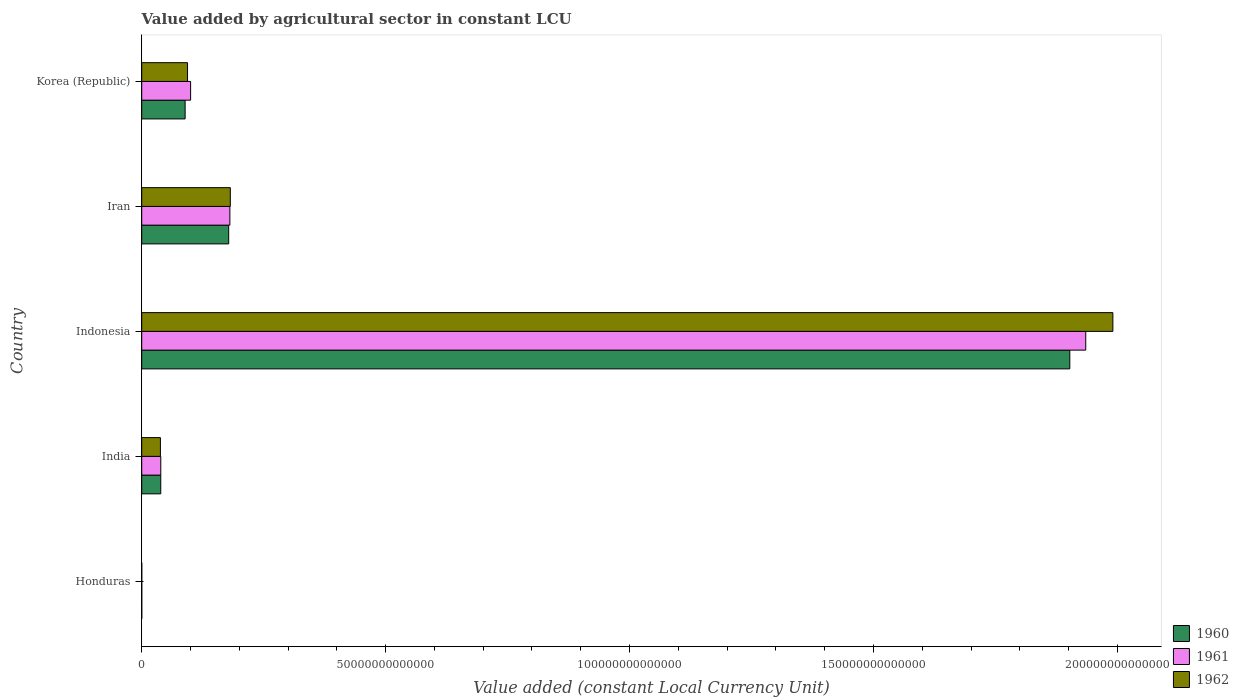Are the number of bars per tick equal to the number of legend labels?
Provide a succinct answer. Yes. Are the number of bars on each tick of the Y-axis equal?
Keep it short and to the point. Yes. How many bars are there on the 4th tick from the top?
Provide a short and direct response. 3. In how many cases, is the number of bars for a given country not equal to the number of legend labels?
Offer a very short reply. 0. What is the value added by agricultural sector in 1962 in Korea (Republic)?
Your response must be concise. 9.39e+12. Across all countries, what is the maximum value added by agricultural sector in 1962?
Ensure brevity in your answer.  1.99e+14. Across all countries, what is the minimum value added by agricultural sector in 1962?
Your response must be concise. 4.96e+09. In which country was the value added by agricultural sector in 1960 maximum?
Provide a succinct answer. Indonesia. In which country was the value added by agricultural sector in 1960 minimum?
Provide a short and direct response. Honduras. What is the total value added by agricultural sector in 1960 in the graph?
Provide a short and direct response. 2.21e+14. What is the difference between the value added by agricultural sector in 1962 in Honduras and that in Indonesia?
Your response must be concise. -1.99e+14. What is the difference between the value added by agricultural sector in 1961 in India and the value added by agricultural sector in 1960 in Korea (Republic)?
Give a very brief answer. -4.99e+12. What is the average value added by agricultural sector in 1962 per country?
Give a very brief answer. 4.61e+13. What is the difference between the value added by agricultural sector in 1962 and value added by agricultural sector in 1961 in Indonesia?
Provide a succinct answer. 5.56e+12. What is the ratio of the value added by agricultural sector in 1962 in Honduras to that in Korea (Republic)?
Your answer should be very brief. 0. Is the value added by agricultural sector in 1960 in Honduras less than that in Korea (Republic)?
Your response must be concise. Yes. What is the difference between the highest and the second highest value added by agricultural sector in 1962?
Your answer should be compact. 1.81e+14. What is the difference between the highest and the lowest value added by agricultural sector in 1960?
Your answer should be very brief. 1.90e+14. In how many countries, is the value added by agricultural sector in 1961 greater than the average value added by agricultural sector in 1961 taken over all countries?
Make the answer very short. 1. Is the sum of the value added by agricultural sector in 1962 in Indonesia and Iran greater than the maximum value added by agricultural sector in 1961 across all countries?
Provide a succinct answer. Yes. What does the 1st bar from the bottom in Korea (Republic) represents?
Make the answer very short. 1960. How many bars are there?
Provide a short and direct response. 15. Are all the bars in the graph horizontal?
Keep it short and to the point. Yes. How many countries are there in the graph?
Your answer should be compact. 5. What is the difference between two consecutive major ticks on the X-axis?
Your response must be concise. 5.00e+13. Are the values on the major ticks of X-axis written in scientific E-notation?
Your answer should be compact. No. Does the graph contain grids?
Your answer should be compact. No. How are the legend labels stacked?
Your response must be concise. Vertical. What is the title of the graph?
Ensure brevity in your answer.  Value added by agricultural sector in constant LCU. What is the label or title of the X-axis?
Your answer should be very brief. Value added (constant Local Currency Unit). What is the label or title of the Y-axis?
Give a very brief answer. Country. What is the Value added (constant Local Currency Unit) of 1960 in Honduras?
Offer a terse response. 4.44e+09. What is the Value added (constant Local Currency Unit) of 1961 in Honduras?
Provide a short and direct response. 4.73e+09. What is the Value added (constant Local Currency Unit) in 1962 in Honduras?
Ensure brevity in your answer.  4.96e+09. What is the Value added (constant Local Currency Unit) of 1960 in India?
Offer a terse response. 3.90e+12. What is the Value added (constant Local Currency Unit) in 1961 in India?
Offer a very short reply. 3.91e+12. What is the Value added (constant Local Currency Unit) of 1962 in India?
Offer a terse response. 3.83e+12. What is the Value added (constant Local Currency Unit) in 1960 in Indonesia?
Keep it short and to the point. 1.90e+14. What is the Value added (constant Local Currency Unit) in 1961 in Indonesia?
Ensure brevity in your answer.  1.94e+14. What is the Value added (constant Local Currency Unit) in 1962 in Indonesia?
Provide a succinct answer. 1.99e+14. What is the Value added (constant Local Currency Unit) in 1960 in Iran?
Give a very brief answer. 1.78e+13. What is the Value added (constant Local Currency Unit) of 1961 in Iran?
Offer a terse response. 1.81e+13. What is the Value added (constant Local Currency Unit) in 1962 in Iran?
Provide a succinct answer. 1.82e+13. What is the Value added (constant Local Currency Unit) in 1960 in Korea (Republic)?
Provide a succinct answer. 8.90e+12. What is the Value added (constant Local Currency Unit) in 1961 in Korea (Republic)?
Provide a succinct answer. 1.00e+13. What is the Value added (constant Local Currency Unit) of 1962 in Korea (Republic)?
Make the answer very short. 9.39e+12. Across all countries, what is the maximum Value added (constant Local Currency Unit) in 1960?
Keep it short and to the point. 1.90e+14. Across all countries, what is the maximum Value added (constant Local Currency Unit) in 1961?
Ensure brevity in your answer.  1.94e+14. Across all countries, what is the maximum Value added (constant Local Currency Unit) in 1962?
Your response must be concise. 1.99e+14. Across all countries, what is the minimum Value added (constant Local Currency Unit) in 1960?
Your answer should be very brief. 4.44e+09. Across all countries, what is the minimum Value added (constant Local Currency Unit) of 1961?
Ensure brevity in your answer.  4.73e+09. Across all countries, what is the minimum Value added (constant Local Currency Unit) in 1962?
Your answer should be compact. 4.96e+09. What is the total Value added (constant Local Currency Unit) of 1960 in the graph?
Your answer should be compact. 2.21e+14. What is the total Value added (constant Local Currency Unit) of 1961 in the graph?
Provide a short and direct response. 2.26e+14. What is the total Value added (constant Local Currency Unit) of 1962 in the graph?
Make the answer very short. 2.30e+14. What is the difference between the Value added (constant Local Currency Unit) in 1960 in Honduras and that in India?
Make the answer very short. -3.90e+12. What is the difference between the Value added (constant Local Currency Unit) of 1961 in Honduras and that in India?
Give a very brief answer. -3.90e+12. What is the difference between the Value added (constant Local Currency Unit) of 1962 in Honduras and that in India?
Your answer should be compact. -3.82e+12. What is the difference between the Value added (constant Local Currency Unit) in 1960 in Honduras and that in Indonesia?
Offer a very short reply. -1.90e+14. What is the difference between the Value added (constant Local Currency Unit) in 1961 in Honduras and that in Indonesia?
Your answer should be compact. -1.94e+14. What is the difference between the Value added (constant Local Currency Unit) in 1962 in Honduras and that in Indonesia?
Offer a terse response. -1.99e+14. What is the difference between the Value added (constant Local Currency Unit) of 1960 in Honduras and that in Iran?
Ensure brevity in your answer.  -1.78e+13. What is the difference between the Value added (constant Local Currency Unit) of 1961 in Honduras and that in Iran?
Offer a very short reply. -1.81e+13. What is the difference between the Value added (constant Local Currency Unit) of 1962 in Honduras and that in Iran?
Offer a very short reply. -1.82e+13. What is the difference between the Value added (constant Local Currency Unit) of 1960 in Honduras and that in Korea (Republic)?
Offer a very short reply. -8.89e+12. What is the difference between the Value added (constant Local Currency Unit) of 1961 in Honduras and that in Korea (Republic)?
Your answer should be compact. -1.00e+13. What is the difference between the Value added (constant Local Currency Unit) in 1962 in Honduras and that in Korea (Republic)?
Keep it short and to the point. -9.39e+12. What is the difference between the Value added (constant Local Currency Unit) in 1960 in India and that in Indonesia?
Keep it short and to the point. -1.86e+14. What is the difference between the Value added (constant Local Currency Unit) in 1961 in India and that in Indonesia?
Offer a very short reply. -1.90e+14. What is the difference between the Value added (constant Local Currency Unit) in 1962 in India and that in Indonesia?
Offer a very short reply. -1.95e+14. What is the difference between the Value added (constant Local Currency Unit) in 1960 in India and that in Iran?
Your response must be concise. -1.39e+13. What is the difference between the Value added (constant Local Currency Unit) in 1961 in India and that in Iran?
Your response must be concise. -1.42e+13. What is the difference between the Value added (constant Local Currency Unit) of 1962 in India and that in Iran?
Offer a terse response. -1.43e+13. What is the difference between the Value added (constant Local Currency Unit) of 1960 in India and that in Korea (Republic)?
Make the answer very short. -4.99e+12. What is the difference between the Value added (constant Local Currency Unit) in 1961 in India and that in Korea (Republic)?
Keep it short and to the point. -6.11e+12. What is the difference between the Value added (constant Local Currency Unit) in 1962 in India and that in Korea (Republic)?
Your response must be concise. -5.56e+12. What is the difference between the Value added (constant Local Currency Unit) in 1960 in Indonesia and that in Iran?
Keep it short and to the point. 1.72e+14. What is the difference between the Value added (constant Local Currency Unit) in 1961 in Indonesia and that in Iran?
Your answer should be compact. 1.75e+14. What is the difference between the Value added (constant Local Currency Unit) of 1962 in Indonesia and that in Iran?
Provide a succinct answer. 1.81e+14. What is the difference between the Value added (constant Local Currency Unit) of 1960 in Indonesia and that in Korea (Republic)?
Provide a short and direct response. 1.81e+14. What is the difference between the Value added (constant Local Currency Unit) of 1961 in Indonesia and that in Korea (Republic)?
Provide a succinct answer. 1.83e+14. What is the difference between the Value added (constant Local Currency Unit) of 1962 in Indonesia and that in Korea (Republic)?
Give a very brief answer. 1.90e+14. What is the difference between the Value added (constant Local Currency Unit) in 1960 in Iran and that in Korea (Republic)?
Ensure brevity in your answer.  8.93e+12. What is the difference between the Value added (constant Local Currency Unit) of 1961 in Iran and that in Korea (Republic)?
Ensure brevity in your answer.  8.05e+12. What is the difference between the Value added (constant Local Currency Unit) of 1962 in Iran and that in Korea (Republic)?
Provide a short and direct response. 8.77e+12. What is the difference between the Value added (constant Local Currency Unit) in 1960 in Honduras and the Value added (constant Local Currency Unit) in 1961 in India?
Your response must be concise. -3.90e+12. What is the difference between the Value added (constant Local Currency Unit) of 1960 in Honduras and the Value added (constant Local Currency Unit) of 1962 in India?
Provide a succinct answer. -3.83e+12. What is the difference between the Value added (constant Local Currency Unit) in 1961 in Honduras and the Value added (constant Local Currency Unit) in 1962 in India?
Offer a very short reply. -3.83e+12. What is the difference between the Value added (constant Local Currency Unit) in 1960 in Honduras and the Value added (constant Local Currency Unit) in 1961 in Indonesia?
Your answer should be compact. -1.94e+14. What is the difference between the Value added (constant Local Currency Unit) in 1960 in Honduras and the Value added (constant Local Currency Unit) in 1962 in Indonesia?
Your answer should be compact. -1.99e+14. What is the difference between the Value added (constant Local Currency Unit) of 1961 in Honduras and the Value added (constant Local Currency Unit) of 1962 in Indonesia?
Provide a short and direct response. -1.99e+14. What is the difference between the Value added (constant Local Currency Unit) of 1960 in Honduras and the Value added (constant Local Currency Unit) of 1961 in Iran?
Your answer should be compact. -1.81e+13. What is the difference between the Value added (constant Local Currency Unit) of 1960 in Honduras and the Value added (constant Local Currency Unit) of 1962 in Iran?
Your answer should be compact. -1.82e+13. What is the difference between the Value added (constant Local Currency Unit) in 1961 in Honduras and the Value added (constant Local Currency Unit) in 1962 in Iran?
Offer a very short reply. -1.82e+13. What is the difference between the Value added (constant Local Currency Unit) in 1960 in Honduras and the Value added (constant Local Currency Unit) in 1961 in Korea (Republic)?
Your answer should be very brief. -1.00e+13. What is the difference between the Value added (constant Local Currency Unit) of 1960 in Honduras and the Value added (constant Local Currency Unit) of 1962 in Korea (Republic)?
Offer a very short reply. -9.39e+12. What is the difference between the Value added (constant Local Currency Unit) of 1961 in Honduras and the Value added (constant Local Currency Unit) of 1962 in Korea (Republic)?
Give a very brief answer. -9.39e+12. What is the difference between the Value added (constant Local Currency Unit) in 1960 in India and the Value added (constant Local Currency Unit) in 1961 in Indonesia?
Offer a terse response. -1.90e+14. What is the difference between the Value added (constant Local Currency Unit) in 1960 in India and the Value added (constant Local Currency Unit) in 1962 in Indonesia?
Your response must be concise. -1.95e+14. What is the difference between the Value added (constant Local Currency Unit) of 1961 in India and the Value added (constant Local Currency Unit) of 1962 in Indonesia?
Your response must be concise. -1.95e+14. What is the difference between the Value added (constant Local Currency Unit) of 1960 in India and the Value added (constant Local Currency Unit) of 1961 in Iran?
Your answer should be compact. -1.42e+13. What is the difference between the Value added (constant Local Currency Unit) in 1960 in India and the Value added (constant Local Currency Unit) in 1962 in Iran?
Keep it short and to the point. -1.43e+13. What is the difference between the Value added (constant Local Currency Unit) in 1961 in India and the Value added (constant Local Currency Unit) in 1962 in Iran?
Ensure brevity in your answer.  -1.43e+13. What is the difference between the Value added (constant Local Currency Unit) of 1960 in India and the Value added (constant Local Currency Unit) of 1961 in Korea (Republic)?
Ensure brevity in your answer.  -6.12e+12. What is the difference between the Value added (constant Local Currency Unit) of 1960 in India and the Value added (constant Local Currency Unit) of 1962 in Korea (Republic)?
Ensure brevity in your answer.  -5.49e+12. What is the difference between the Value added (constant Local Currency Unit) in 1961 in India and the Value added (constant Local Currency Unit) in 1962 in Korea (Republic)?
Offer a very short reply. -5.48e+12. What is the difference between the Value added (constant Local Currency Unit) of 1960 in Indonesia and the Value added (constant Local Currency Unit) of 1961 in Iran?
Ensure brevity in your answer.  1.72e+14. What is the difference between the Value added (constant Local Currency Unit) in 1960 in Indonesia and the Value added (constant Local Currency Unit) in 1962 in Iran?
Provide a short and direct response. 1.72e+14. What is the difference between the Value added (constant Local Currency Unit) of 1961 in Indonesia and the Value added (constant Local Currency Unit) of 1962 in Iran?
Ensure brevity in your answer.  1.75e+14. What is the difference between the Value added (constant Local Currency Unit) in 1960 in Indonesia and the Value added (constant Local Currency Unit) in 1961 in Korea (Republic)?
Provide a short and direct response. 1.80e+14. What is the difference between the Value added (constant Local Currency Unit) in 1960 in Indonesia and the Value added (constant Local Currency Unit) in 1962 in Korea (Republic)?
Offer a terse response. 1.81e+14. What is the difference between the Value added (constant Local Currency Unit) of 1961 in Indonesia and the Value added (constant Local Currency Unit) of 1962 in Korea (Republic)?
Ensure brevity in your answer.  1.84e+14. What is the difference between the Value added (constant Local Currency Unit) of 1960 in Iran and the Value added (constant Local Currency Unit) of 1961 in Korea (Republic)?
Give a very brief answer. 7.81e+12. What is the difference between the Value added (constant Local Currency Unit) in 1960 in Iran and the Value added (constant Local Currency Unit) in 1962 in Korea (Republic)?
Provide a succinct answer. 8.44e+12. What is the difference between the Value added (constant Local Currency Unit) of 1961 in Iran and the Value added (constant Local Currency Unit) of 1962 in Korea (Republic)?
Give a very brief answer. 8.68e+12. What is the average Value added (constant Local Currency Unit) of 1960 per country?
Give a very brief answer. 4.42e+13. What is the average Value added (constant Local Currency Unit) of 1961 per country?
Make the answer very short. 4.51e+13. What is the average Value added (constant Local Currency Unit) in 1962 per country?
Provide a short and direct response. 4.61e+13. What is the difference between the Value added (constant Local Currency Unit) of 1960 and Value added (constant Local Currency Unit) of 1961 in Honduras?
Keep it short and to the point. -2.90e+08. What is the difference between the Value added (constant Local Currency Unit) in 1960 and Value added (constant Local Currency Unit) in 1962 in Honduras?
Your answer should be compact. -5.15e+08. What is the difference between the Value added (constant Local Currency Unit) in 1961 and Value added (constant Local Currency Unit) in 1962 in Honduras?
Your response must be concise. -2.25e+08. What is the difference between the Value added (constant Local Currency Unit) in 1960 and Value added (constant Local Currency Unit) in 1961 in India?
Offer a terse response. -3.29e+09. What is the difference between the Value added (constant Local Currency Unit) of 1960 and Value added (constant Local Currency Unit) of 1962 in India?
Ensure brevity in your answer.  7.44e+1. What is the difference between the Value added (constant Local Currency Unit) of 1961 and Value added (constant Local Currency Unit) of 1962 in India?
Provide a short and direct response. 7.77e+1. What is the difference between the Value added (constant Local Currency Unit) in 1960 and Value added (constant Local Currency Unit) in 1961 in Indonesia?
Provide a short and direct response. -3.27e+12. What is the difference between the Value added (constant Local Currency Unit) in 1960 and Value added (constant Local Currency Unit) in 1962 in Indonesia?
Your answer should be very brief. -8.83e+12. What is the difference between the Value added (constant Local Currency Unit) of 1961 and Value added (constant Local Currency Unit) of 1962 in Indonesia?
Keep it short and to the point. -5.56e+12. What is the difference between the Value added (constant Local Currency Unit) of 1960 and Value added (constant Local Currency Unit) of 1961 in Iran?
Give a very brief answer. -2.42e+11. What is the difference between the Value added (constant Local Currency Unit) of 1960 and Value added (constant Local Currency Unit) of 1962 in Iran?
Provide a short and direct response. -3.32e+11. What is the difference between the Value added (constant Local Currency Unit) of 1961 and Value added (constant Local Currency Unit) of 1962 in Iran?
Offer a very short reply. -8.95e+1. What is the difference between the Value added (constant Local Currency Unit) in 1960 and Value added (constant Local Currency Unit) in 1961 in Korea (Republic)?
Give a very brief answer. -1.12e+12. What is the difference between the Value added (constant Local Currency Unit) in 1960 and Value added (constant Local Currency Unit) in 1962 in Korea (Republic)?
Your answer should be very brief. -4.93e+11. What is the difference between the Value added (constant Local Currency Unit) in 1961 and Value added (constant Local Currency Unit) in 1962 in Korea (Republic)?
Offer a terse response. 6.31e+11. What is the ratio of the Value added (constant Local Currency Unit) in 1960 in Honduras to that in India?
Make the answer very short. 0. What is the ratio of the Value added (constant Local Currency Unit) in 1961 in Honduras to that in India?
Provide a succinct answer. 0. What is the ratio of the Value added (constant Local Currency Unit) of 1962 in Honduras to that in India?
Give a very brief answer. 0. What is the ratio of the Value added (constant Local Currency Unit) in 1962 in Honduras to that in Iran?
Offer a terse response. 0. What is the ratio of the Value added (constant Local Currency Unit) in 1960 in Honduras to that in Korea (Republic)?
Make the answer very short. 0. What is the ratio of the Value added (constant Local Currency Unit) in 1961 in Honduras to that in Korea (Republic)?
Your answer should be very brief. 0. What is the ratio of the Value added (constant Local Currency Unit) of 1962 in Honduras to that in Korea (Republic)?
Keep it short and to the point. 0. What is the ratio of the Value added (constant Local Currency Unit) in 1960 in India to that in Indonesia?
Provide a succinct answer. 0.02. What is the ratio of the Value added (constant Local Currency Unit) in 1961 in India to that in Indonesia?
Give a very brief answer. 0.02. What is the ratio of the Value added (constant Local Currency Unit) in 1962 in India to that in Indonesia?
Give a very brief answer. 0.02. What is the ratio of the Value added (constant Local Currency Unit) of 1960 in India to that in Iran?
Provide a succinct answer. 0.22. What is the ratio of the Value added (constant Local Currency Unit) in 1961 in India to that in Iran?
Give a very brief answer. 0.22. What is the ratio of the Value added (constant Local Currency Unit) of 1962 in India to that in Iran?
Offer a terse response. 0.21. What is the ratio of the Value added (constant Local Currency Unit) of 1960 in India to that in Korea (Republic)?
Offer a terse response. 0.44. What is the ratio of the Value added (constant Local Currency Unit) in 1961 in India to that in Korea (Republic)?
Offer a terse response. 0.39. What is the ratio of the Value added (constant Local Currency Unit) in 1962 in India to that in Korea (Republic)?
Provide a succinct answer. 0.41. What is the ratio of the Value added (constant Local Currency Unit) in 1960 in Indonesia to that in Iran?
Your answer should be very brief. 10.67. What is the ratio of the Value added (constant Local Currency Unit) in 1961 in Indonesia to that in Iran?
Offer a terse response. 10.71. What is the ratio of the Value added (constant Local Currency Unit) in 1962 in Indonesia to that in Iran?
Your answer should be very brief. 10.96. What is the ratio of the Value added (constant Local Currency Unit) in 1960 in Indonesia to that in Korea (Republic)?
Provide a succinct answer. 21.38. What is the ratio of the Value added (constant Local Currency Unit) of 1961 in Indonesia to that in Korea (Republic)?
Provide a succinct answer. 19.31. What is the ratio of the Value added (constant Local Currency Unit) in 1962 in Indonesia to that in Korea (Republic)?
Offer a very short reply. 21.2. What is the ratio of the Value added (constant Local Currency Unit) in 1960 in Iran to that in Korea (Republic)?
Keep it short and to the point. 2. What is the ratio of the Value added (constant Local Currency Unit) in 1961 in Iran to that in Korea (Republic)?
Your answer should be very brief. 1.8. What is the ratio of the Value added (constant Local Currency Unit) in 1962 in Iran to that in Korea (Republic)?
Your response must be concise. 1.93. What is the difference between the highest and the second highest Value added (constant Local Currency Unit) of 1960?
Give a very brief answer. 1.72e+14. What is the difference between the highest and the second highest Value added (constant Local Currency Unit) in 1961?
Make the answer very short. 1.75e+14. What is the difference between the highest and the second highest Value added (constant Local Currency Unit) of 1962?
Your response must be concise. 1.81e+14. What is the difference between the highest and the lowest Value added (constant Local Currency Unit) in 1960?
Give a very brief answer. 1.90e+14. What is the difference between the highest and the lowest Value added (constant Local Currency Unit) of 1961?
Your answer should be compact. 1.94e+14. What is the difference between the highest and the lowest Value added (constant Local Currency Unit) in 1962?
Offer a terse response. 1.99e+14. 